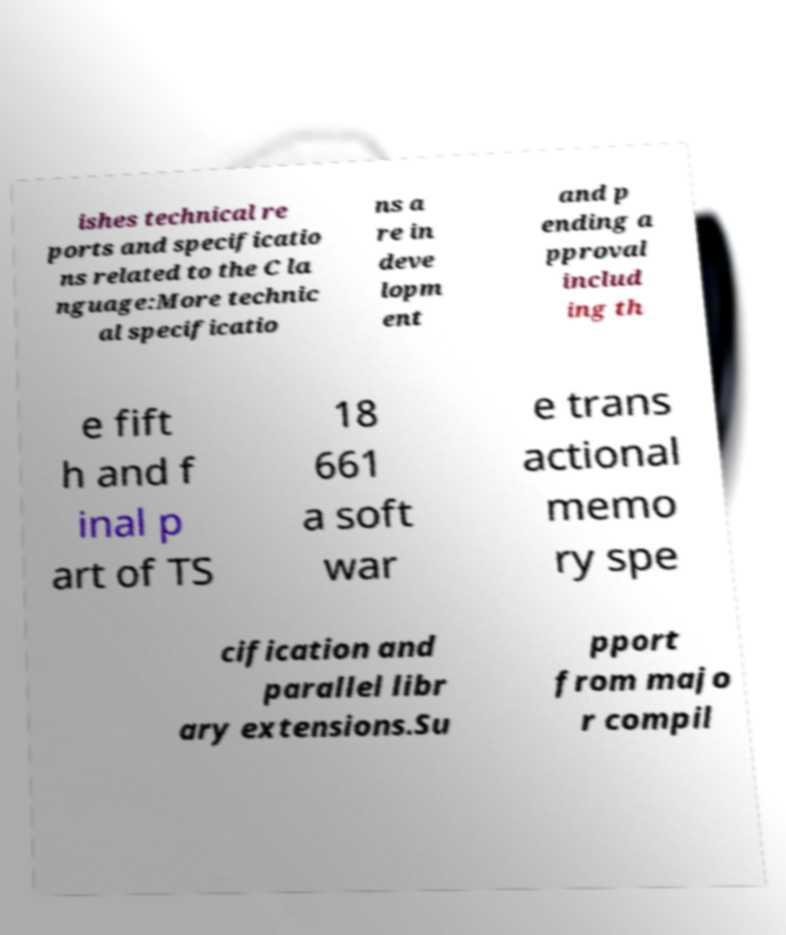Please read and relay the text visible in this image. What does it say? ishes technical re ports and specificatio ns related to the C la nguage:More technic al specificatio ns a re in deve lopm ent and p ending a pproval includ ing th e fift h and f inal p art of TS 18 661 a soft war e trans actional memo ry spe cification and parallel libr ary extensions.Su pport from majo r compil 